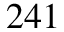Convert formula to latex. <formula><loc_0><loc_0><loc_500><loc_500>^ { 2 4 1 }</formula> 